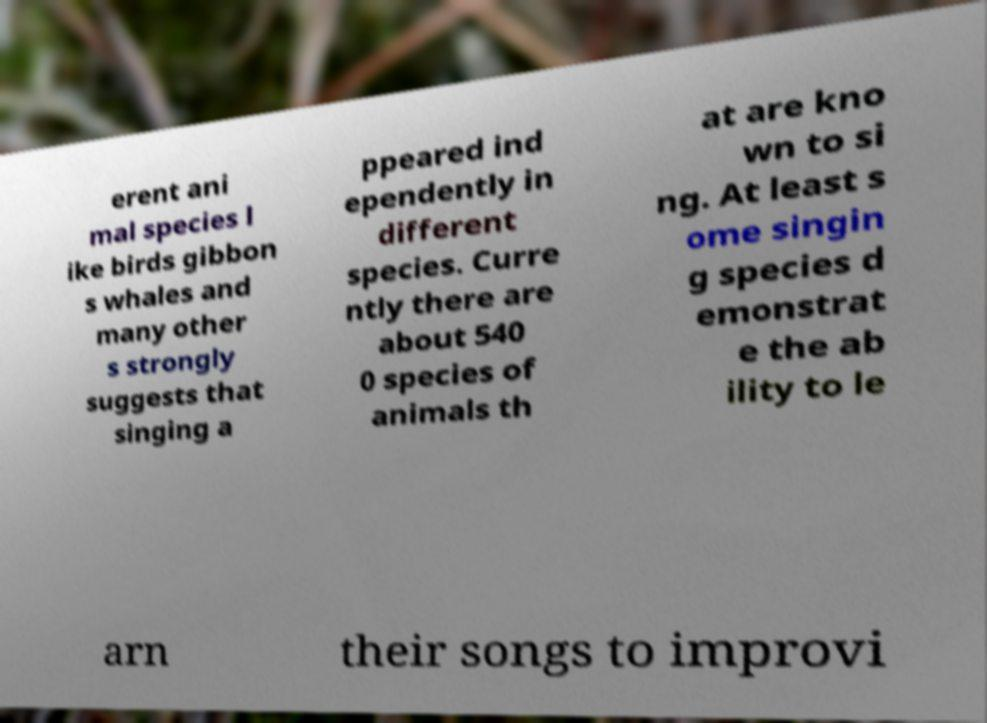What messages or text are displayed in this image? I need them in a readable, typed format. erent ani mal species l ike birds gibbon s whales and many other s strongly suggests that singing a ppeared ind ependently in different species. Curre ntly there are about 540 0 species of animals th at are kno wn to si ng. At least s ome singin g species d emonstrat e the ab ility to le arn their songs to improvi 